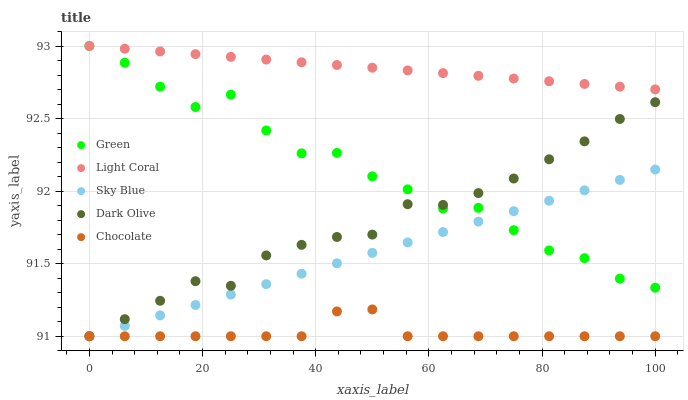Does Chocolate have the minimum area under the curve?
Answer yes or no. Yes. Does Light Coral have the maximum area under the curve?
Answer yes or no. Yes. Does Sky Blue have the minimum area under the curve?
Answer yes or no. No. Does Sky Blue have the maximum area under the curve?
Answer yes or no. No. Is Sky Blue the smoothest?
Answer yes or no. Yes. Is Green the roughest?
Answer yes or no. Yes. Is Dark Olive the smoothest?
Answer yes or no. No. Is Dark Olive the roughest?
Answer yes or no. No. Does Sky Blue have the lowest value?
Answer yes or no. Yes. Does Green have the lowest value?
Answer yes or no. No. Does Green have the highest value?
Answer yes or no. Yes. Does Sky Blue have the highest value?
Answer yes or no. No. Is Chocolate less than Light Coral?
Answer yes or no. Yes. Is Light Coral greater than Sky Blue?
Answer yes or no. Yes. Does Sky Blue intersect Green?
Answer yes or no. Yes. Is Sky Blue less than Green?
Answer yes or no. No. Is Sky Blue greater than Green?
Answer yes or no. No. Does Chocolate intersect Light Coral?
Answer yes or no. No. 